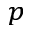<formula> <loc_0><loc_0><loc_500><loc_500>_ { p }</formula> 